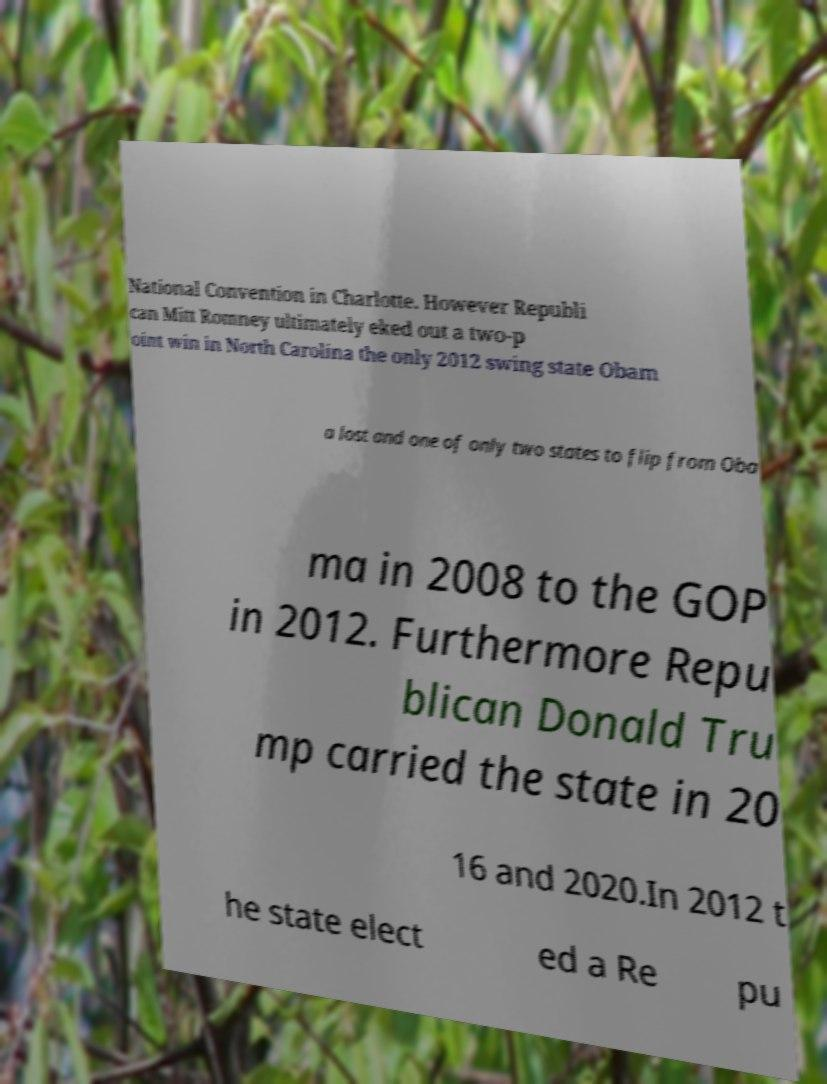Can you accurately transcribe the text from the provided image for me? National Convention in Charlotte. However Republi can Mitt Romney ultimately eked out a two-p oint win in North Carolina the only 2012 swing state Obam a lost and one of only two states to flip from Oba ma in 2008 to the GOP in 2012. Furthermore Repu blican Donald Tru mp carried the state in 20 16 and 2020.In 2012 t he state elect ed a Re pu 